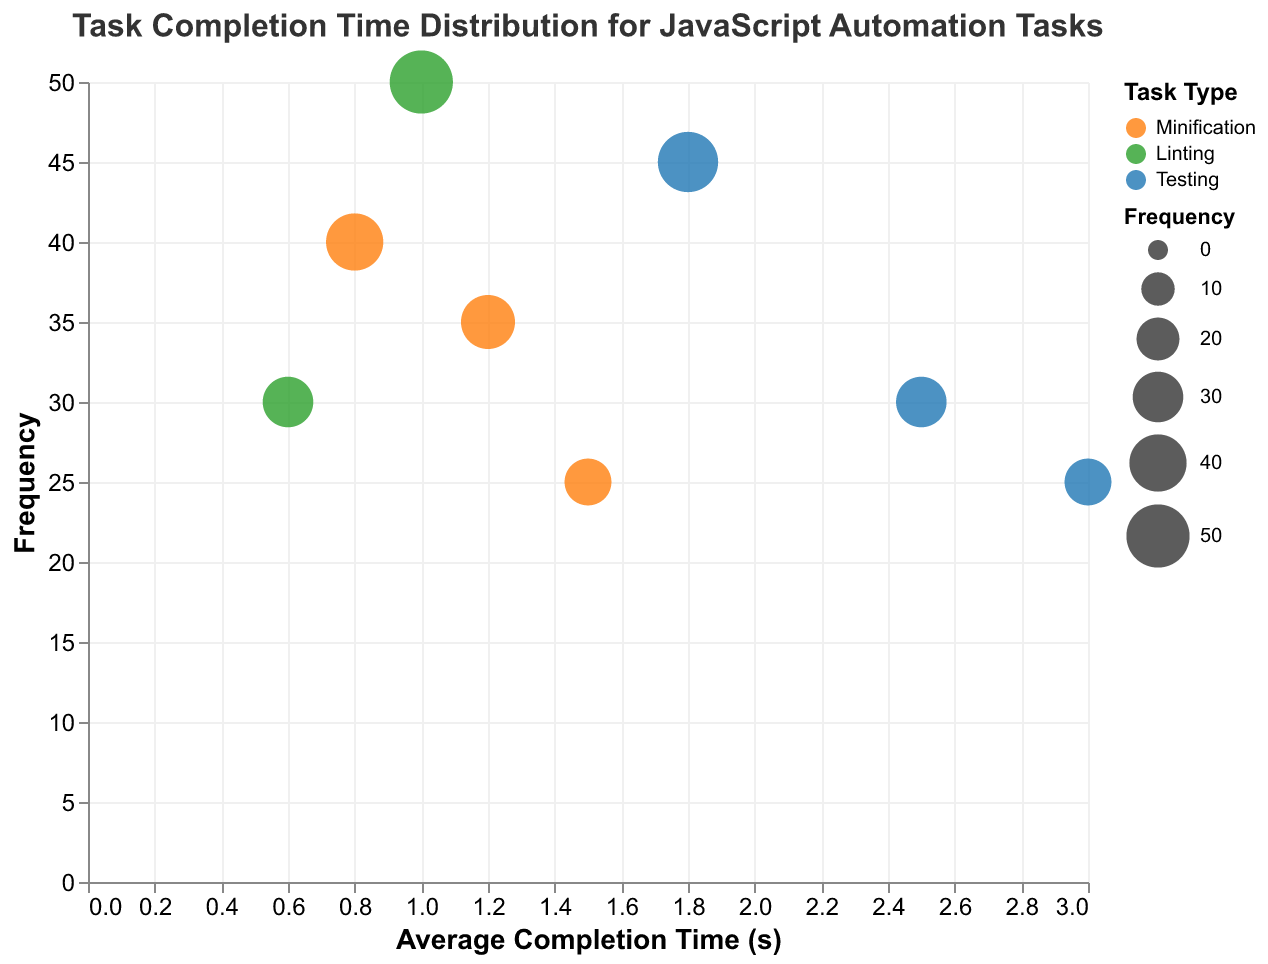What's the task type coding rule? Explanation: The TaskType coding rule is defined in legend with Minification represented in orange, Linting in green, and Testing in blue. By looking at the colors of circles in the Bubble Chart, you can identify their corresponding task types.
Answer: Minification, Linting, Testing Which task type has the highest frequency and what is its frequency? Explanation: By observing the y-axis and the size of the bubbles, the largest and highest frequency point corresponds to "Linting" with 50 occurrences.
Answer: Linting, 50 Which task in the "Testing" category has the longest average completion time? Explanation: In the chart, the blue bubbles represent Testing tasks. The bubble farthest to the right provides the longest average completion time, which corresponds to "UI-Test" with an average completion time of 3.0 seconds.
Answer: UI-Test What is the average completion time (in seconds) for the task with the smallest frequency in the "Minification" category? Explanation: The smallest (least frequent) point in the orange 'Minification' category is "Minify-JS" with a frequency of 25 and an average completion time of 1.5 seconds.
Answer: 1.5 How many different task sizes are represented in the figure, and what are they? Explanation: By checking the tooltip and legend information for any bubble, we find three different task sizes are represented: Small, Medium, and Large.
Answer: Three: Small, Medium, Large Which task has the highest average completion time irrespective of task type? Explanation: The bubble farthest to the right on the x-axis represents the task with the highest average completion time, which corresponds to "UI-Test" with an average completion time of 3.0 seconds.
Answer: UI-Test Among the minification tasks, which one has the smallest task size and what is its frequency? Explanation: The tooltip reveals that "Minify-HTML" is the minification task with a Small size, with a frequency of 40.
Answer: Minify-HTML, 40 Compare the average completion times of "Unit-Test" and "Lint-JS". Which one is shorter, and by how much? Explanation: "Unit-Test" has an average completion time of 1.8 seconds and "Lint-JS" has 1.0 seconds. The difference in average completion time is 1.8 - 1.0 = 0.8 seconds, meaning "Lint-JS" is shorter by 0.8 seconds.
Answer: Lint-JS, by 0.8 seconds What is the most frequent task overall and what is its size? Explanation: The bubble with the largest size and the highest position on the y-axis indicates "Lint-JS" with a frequency of 50 and a size of Medium.
Answer: Lint-JS, Medium How does the task frequency correlate with the task size? Explanation: From the visual representation, Small and Medium size tasks appear more frequently than Large size tasks, indicating smaller-sized tasks tend to be done more often.
Answer: Smaller tasks, more frequent 